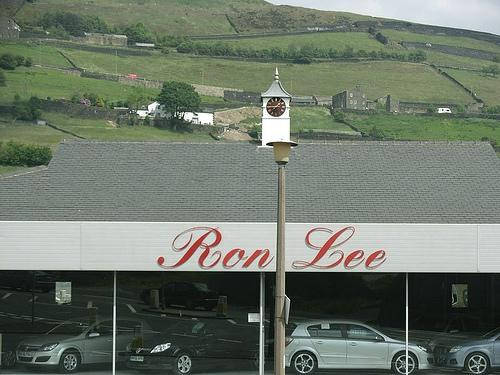What type of sentiment can be associated with the large leafy tree in the image considering its position and size? The large leafy tree evokes a sense of calmness and freshness, as it is positioned near other objects, indicating a harmonious and natural environment. What can you infer about the size and color of the clock in the image? The clock is small and has a brown color with gold numbers. Choose an object interaction from the image and describe it in detail. A silver car's windshield is reflecting parked cars and the street, illustrating a clear and bright day. How many objects in the image are related to vegetation, and what are their colors? There are two vegetation-related objects: a tree with green leaves and a grass area with green grass. Regarding the image quality, mention any significant reflections present. There are reflections of the street and parked cars in the window. Examine the image and provide a brief sentiment analysis based on the objects and elements present. The image depicts a peaceful scene with parked cars, trees, and a hill in the background, conveying a calm and serene atmosphere. Identify the elements in the image that relate to nature and their respective properties. There are trees with green leaves, green grass, and a hill in the image. Count the number of cars present in the image and describe one of them. There are five cars in the image, one of them is a black car with a white license plate. 